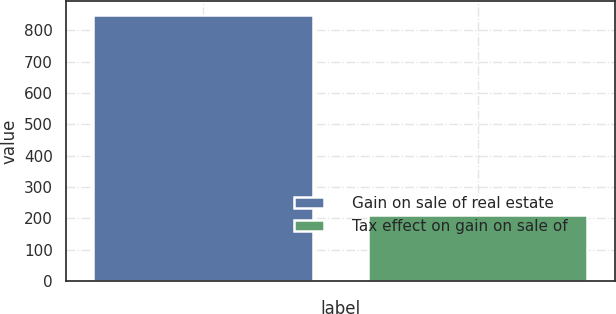Convert chart. <chart><loc_0><loc_0><loc_500><loc_500><bar_chart><fcel>Gain on sale of real estate<fcel>Tax effect on gain on sale of<nl><fcel>850<fcel>209<nl></chart> 